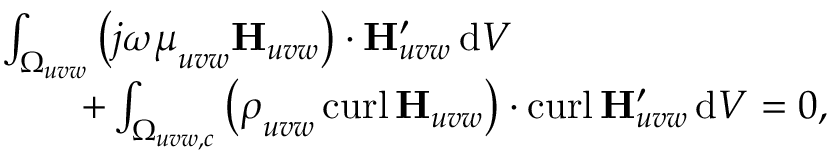Convert formula to latex. <formula><loc_0><loc_0><loc_500><loc_500>\begin{array} { r l } & { \int _ { \Omega _ { u v w } } \left ( j \omega \boldsymbol \mu _ { u v w } H _ { u v w } \right ) \cdot H _ { u v w } ^ { \prime } \, d V \, } \\ & { \quad + \int _ { \Omega _ { u v w , c } } \left ( \boldsymbol \rho _ { u v w } \, c u r l \, H _ { u v w } \right ) \cdot c u r l \, H _ { u v w } ^ { \prime } \, d V = 0 , } \end{array}</formula> 